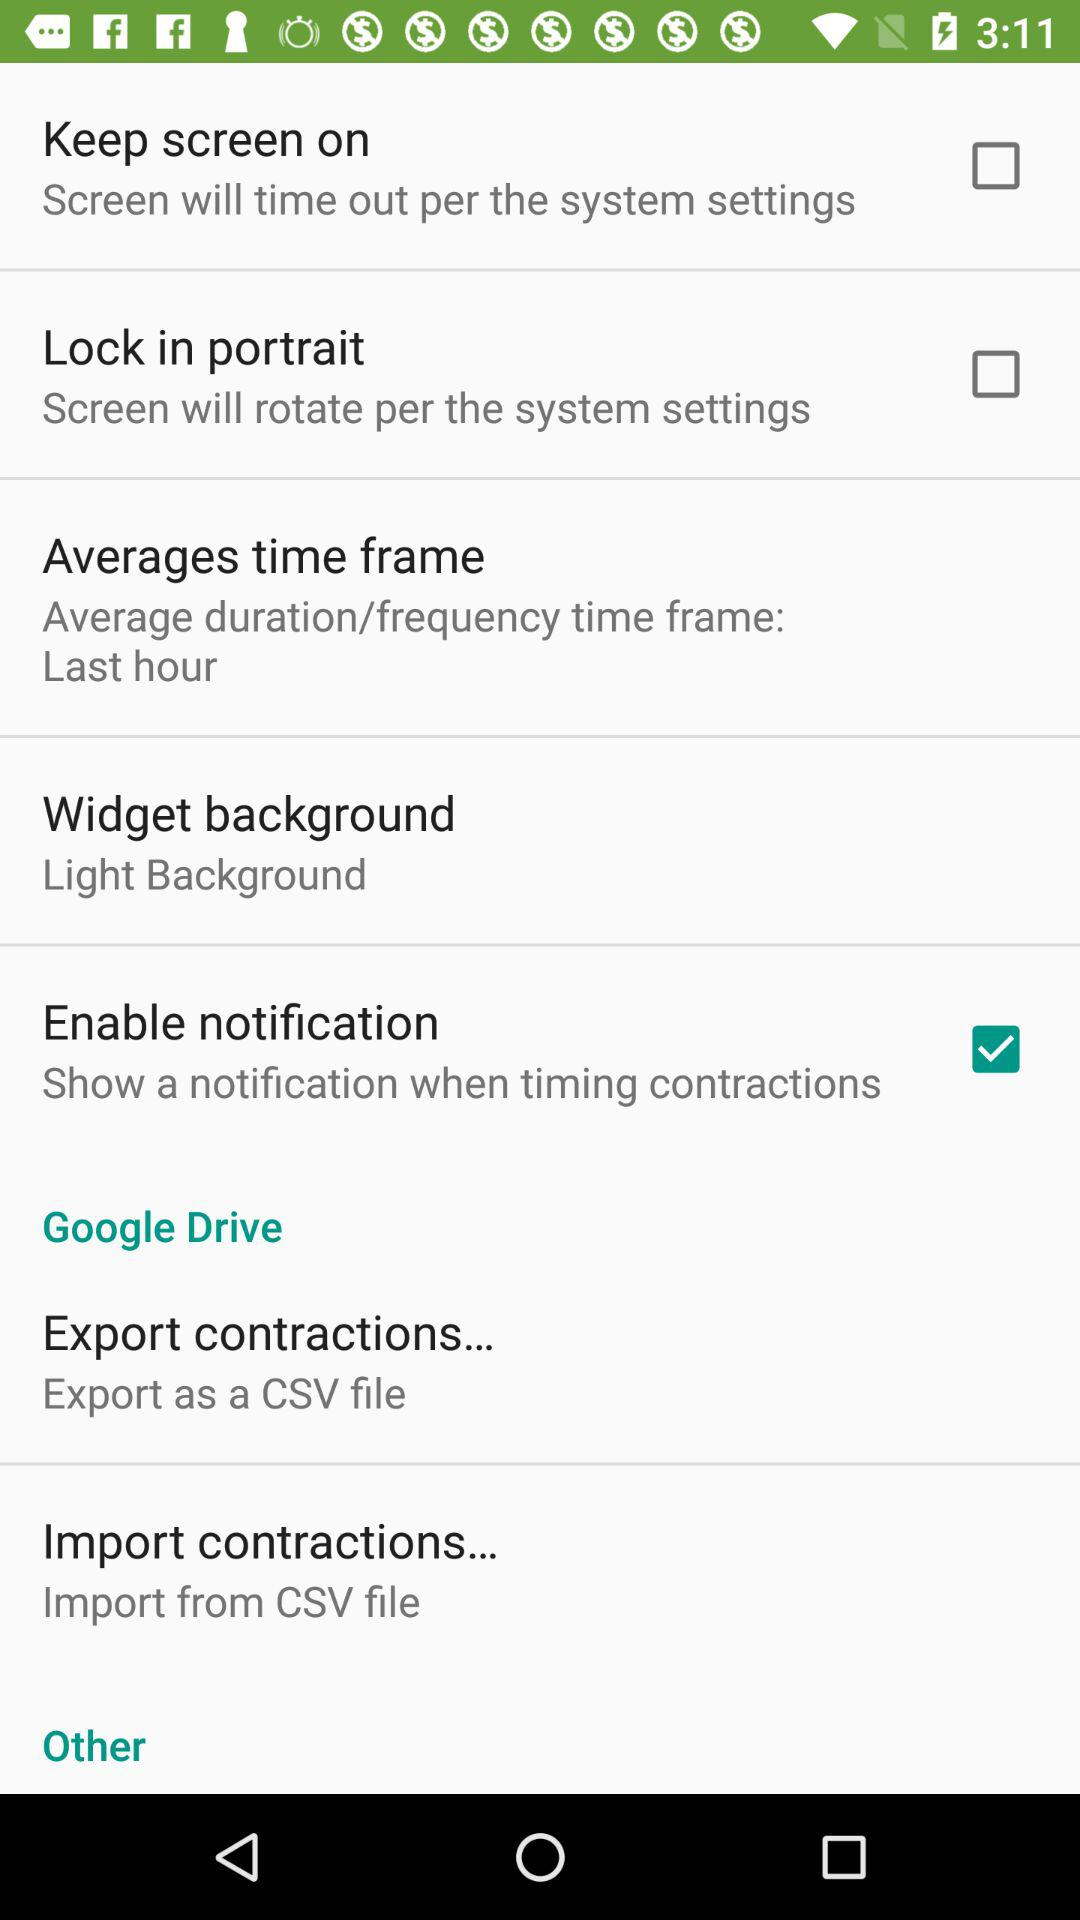To which file can the contractions be exported? The contractions can be exported to a CSV file. 